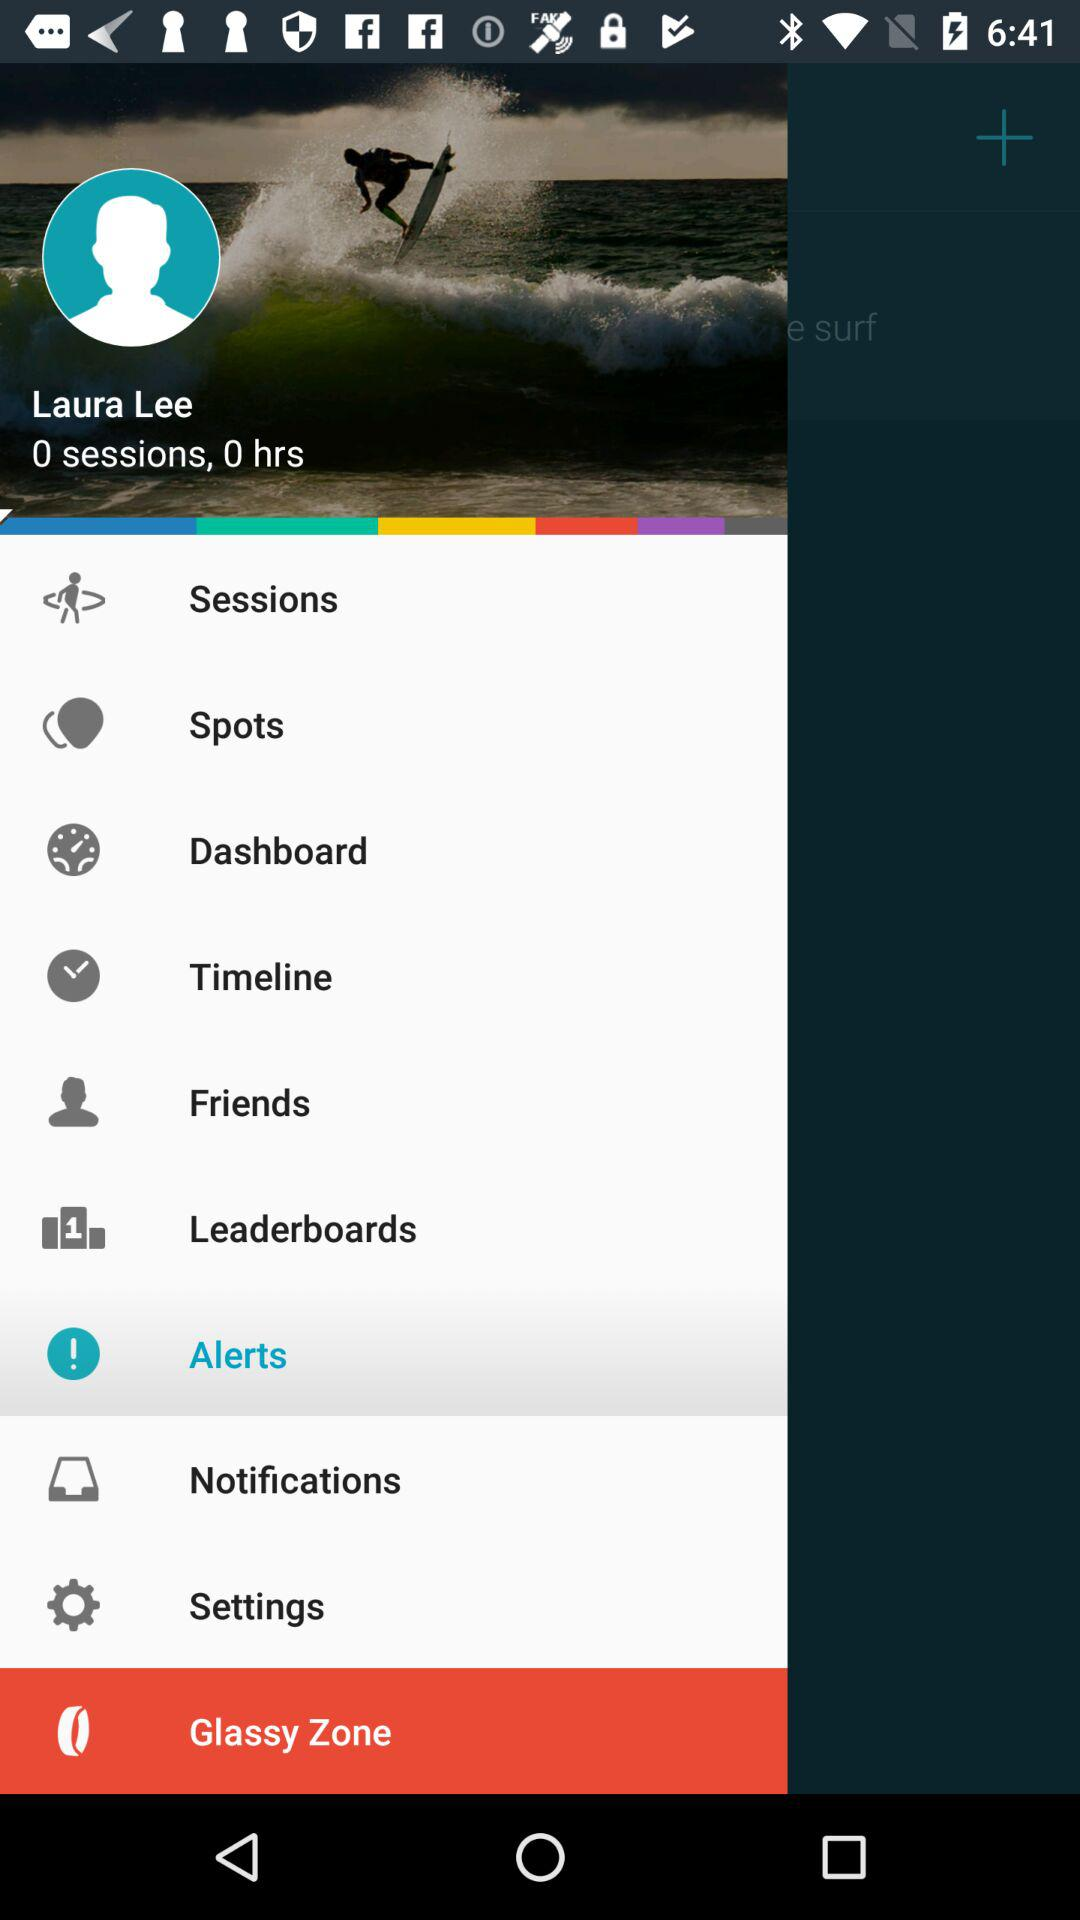Which option is selected? The selected option is Alerts. 